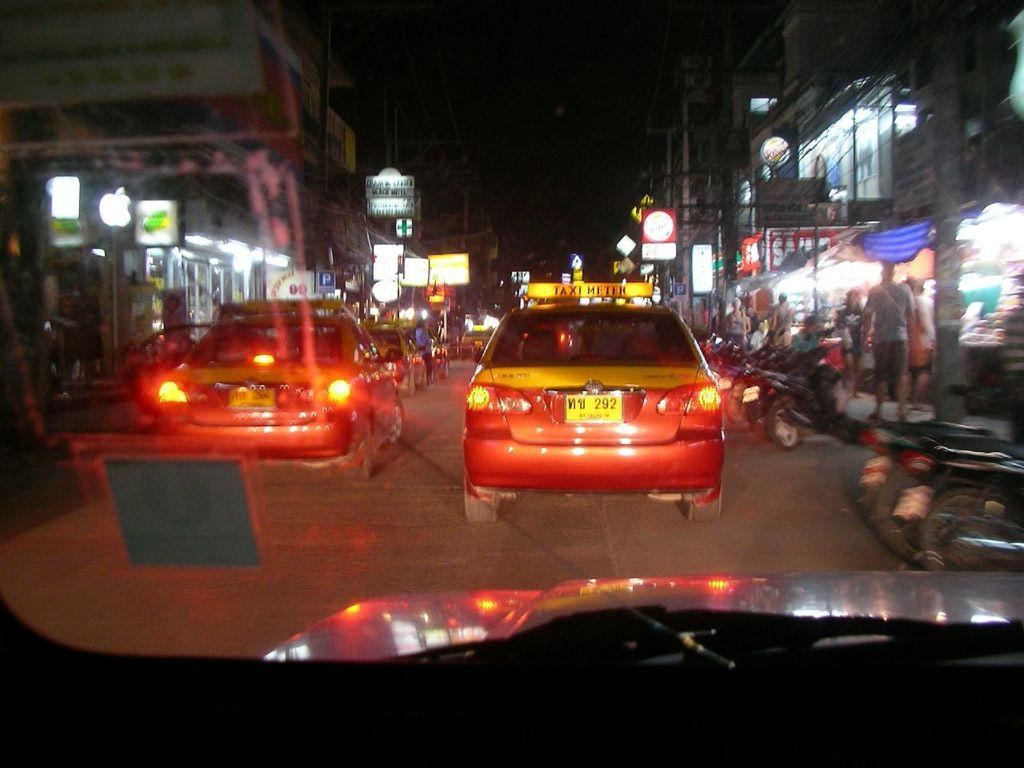<image>
Provide a brief description of the given image. The red car visible has a yellow sign on the roof saying Taxi meter. 